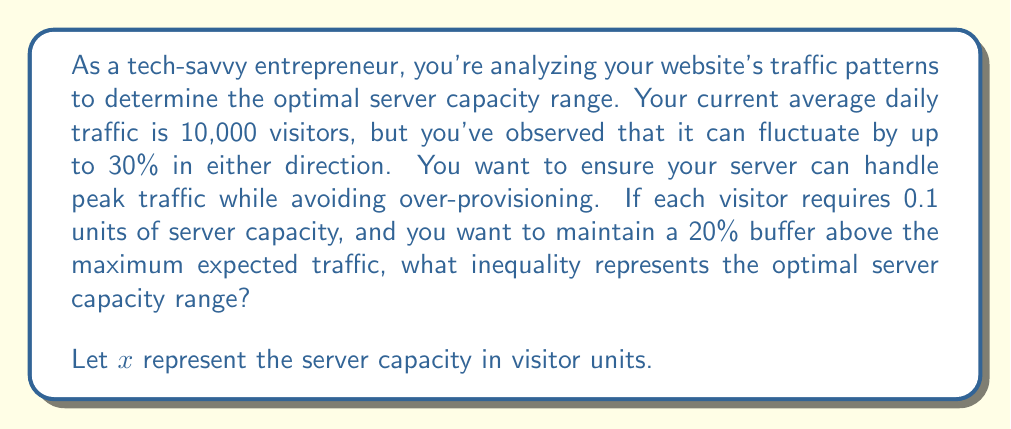Teach me how to tackle this problem. To solve this problem, we'll follow these steps:

1. Calculate the minimum and maximum daily traffic:
   Minimum: $10,000 - (30\% \times 10,000) = 7,000$ visitors
   Maximum: $10,000 + (30\% \times 10,000) = 13,000$ visitors

2. Convert visitor numbers to server capacity units:
   Each visitor requires 0.1 units of server capacity
   Minimum capacity: $7,000 \times 0.1 = 700$ units
   Maximum capacity: $13,000 \times 0.1 = 1,300$ units

3. Add the 20% buffer to the maximum capacity:
   Buffer: $20\% \times 1,300 = 260$ units
   Maximum capacity with buffer: $1,300 + 260 = 1,560$ units

4. Set up the inequality:
   The server capacity $x$ should be greater than or equal to the minimum capacity (700 units) and less than or equal to the maximum capacity with buffer (1,560 units).

   $$700 \leq x \leq 1,560$$

This inequality represents the optimal server capacity range that can handle the traffic fluctuations while maintaining a 20% buffer above the maximum expected traffic.
Answer: $$700 \leq x \leq 1,560$$
Where $x$ represents the server capacity in visitor units. 